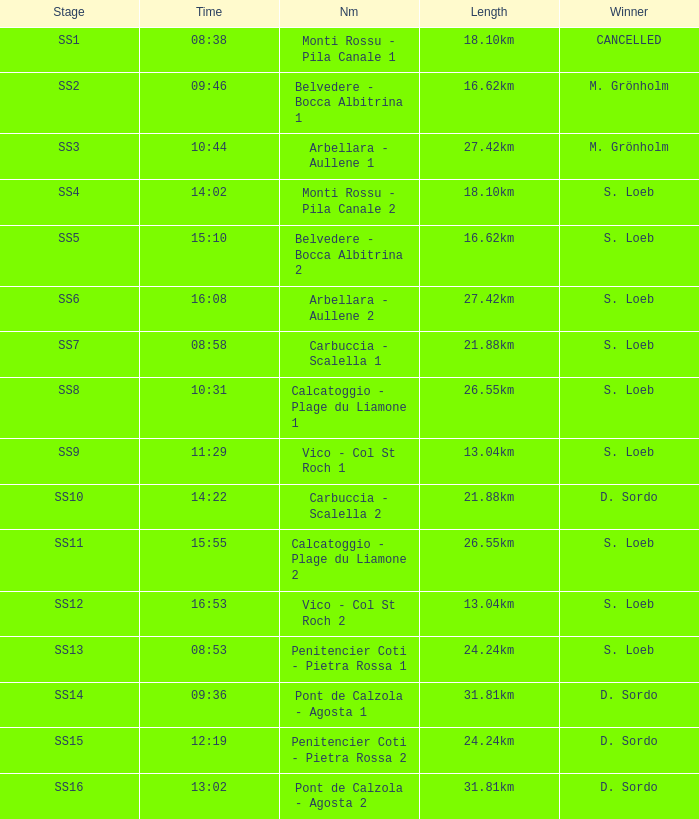What is the Name of the SS5 Stage? Belvedere - Bocca Albitrina 2. 